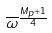Convert formula to latex. <formula><loc_0><loc_0><loc_500><loc_500>\overline { \omega } ^ { \frac { M _ { p } + 1 } { 4 } }</formula> 